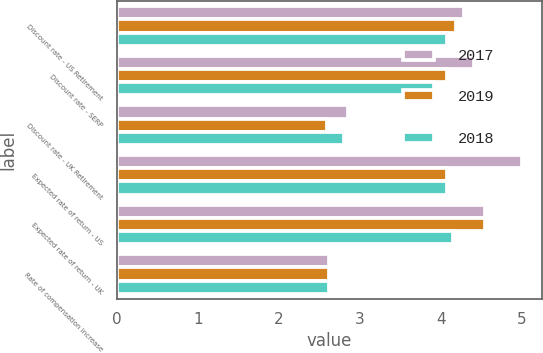Convert chart to OTSL. <chart><loc_0><loc_0><loc_500><loc_500><stacked_bar_chart><ecel><fcel>Discount rate - US Retirement<fcel>Discount rate - SERP<fcel>Discount rate - UK Retirement<fcel>Expected rate of return - US<fcel>Expected rate of return - UK<fcel>Rate of compensation increase<nl><fcel>2017<fcel>4.28<fcel>4.41<fcel>2.85<fcel>5<fcel>4.55<fcel>2.62<nl><fcel>2019<fcel>4.19<fcel>4.08<fcel>2.6<fcel>4.075<fcel>4.55<fcel>2.62<nl><fcel>2018<fcel>4.07<fcel>3.91<fcel>2.8<fcel>4.075<fcel>4.15<fcel>2.62<nl></chart> 